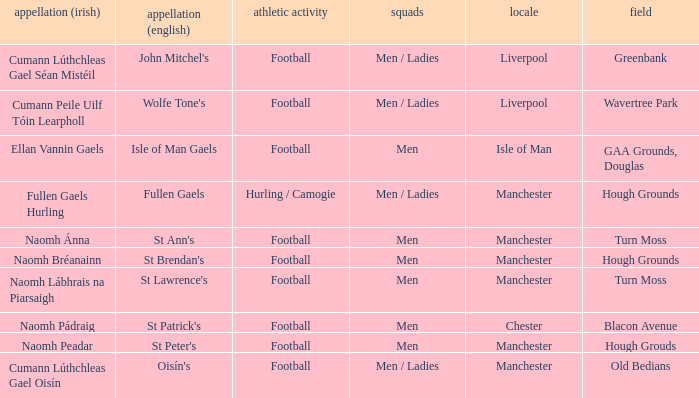What is the English Name of the Location in Chester? St Patrick's. 